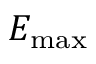<formula> <loc_0><loc_0><loc_500><loc_500>E _ { \max }</formula> 